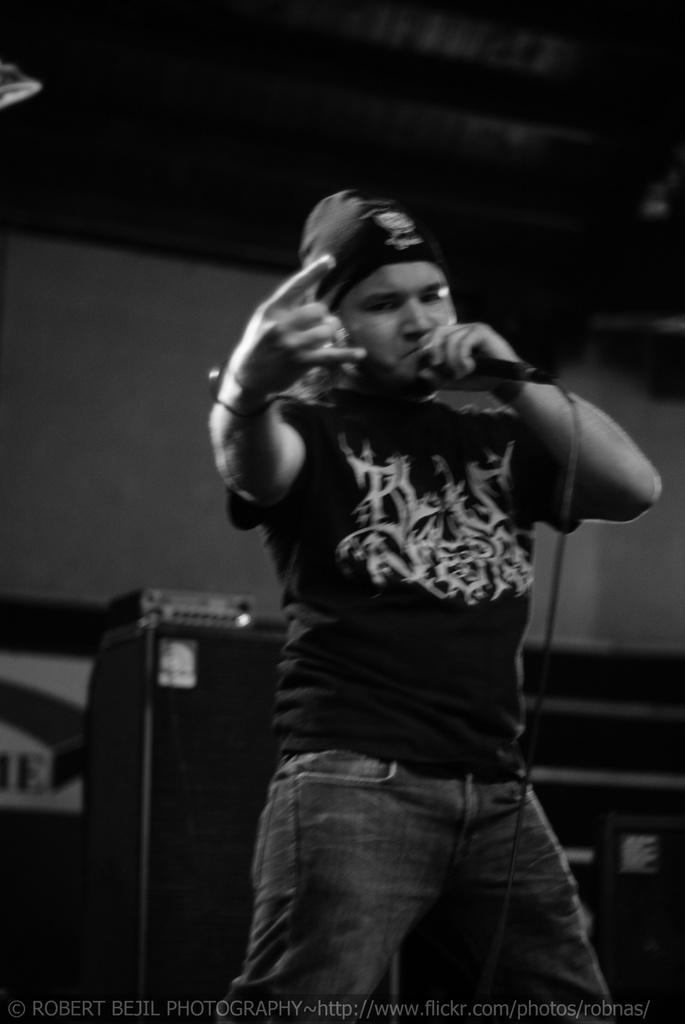Who is present in the image? There is a person in the image. What is the person wearing on their head? The person is wearing a cap. What object is the person holding? The person is holding a microphone. What can be seen in the background of the image? There is a cupboard and a wall in the background. What type of paper is the person reading in the image? There is no paper present in the image; the person is holding a microphone. 